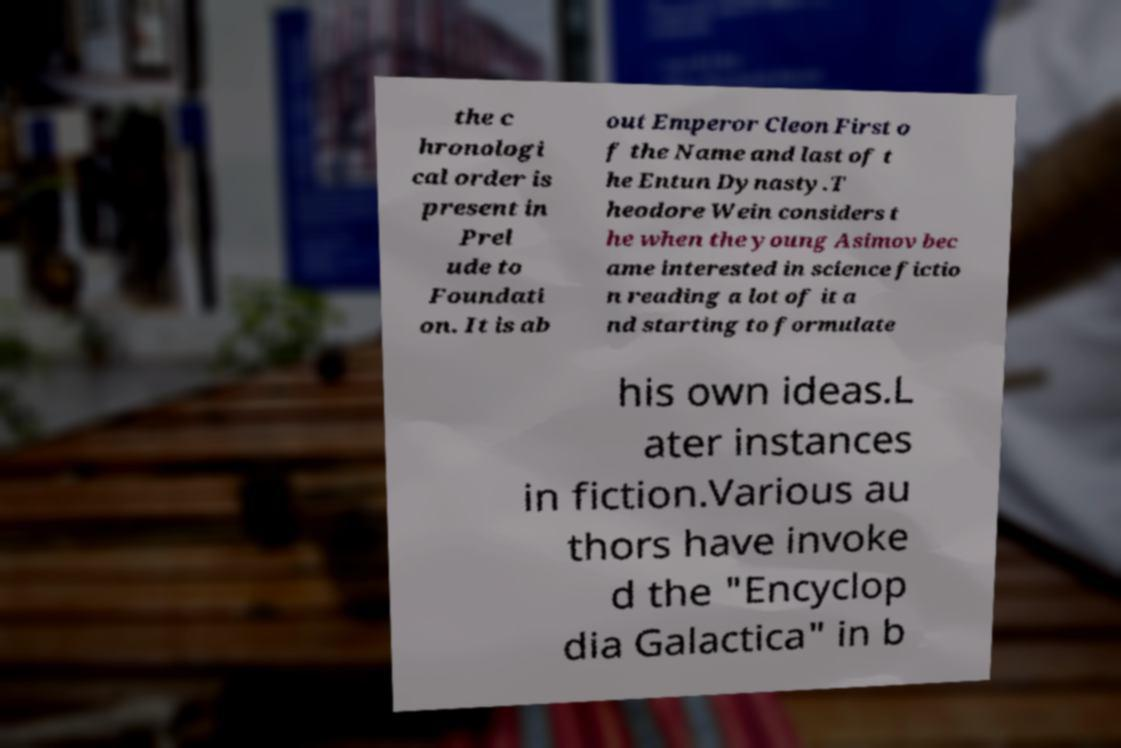Could you assist in decoding the text presented in this image and type it out clearly? the c hronologi cal order is present in Prel ude to Foundati on. It is ab out Emperor Cleon First o f the Name and last of t he Entun Dynasty.T heodore Wein considers t he when the young Asimov bec ame interested in science fictio n reading a lot of it a nd starting to formulate his own ideas.L ater instances in fiction.Various au thors have invoke d the "Encyclop dia Galactica" in b 